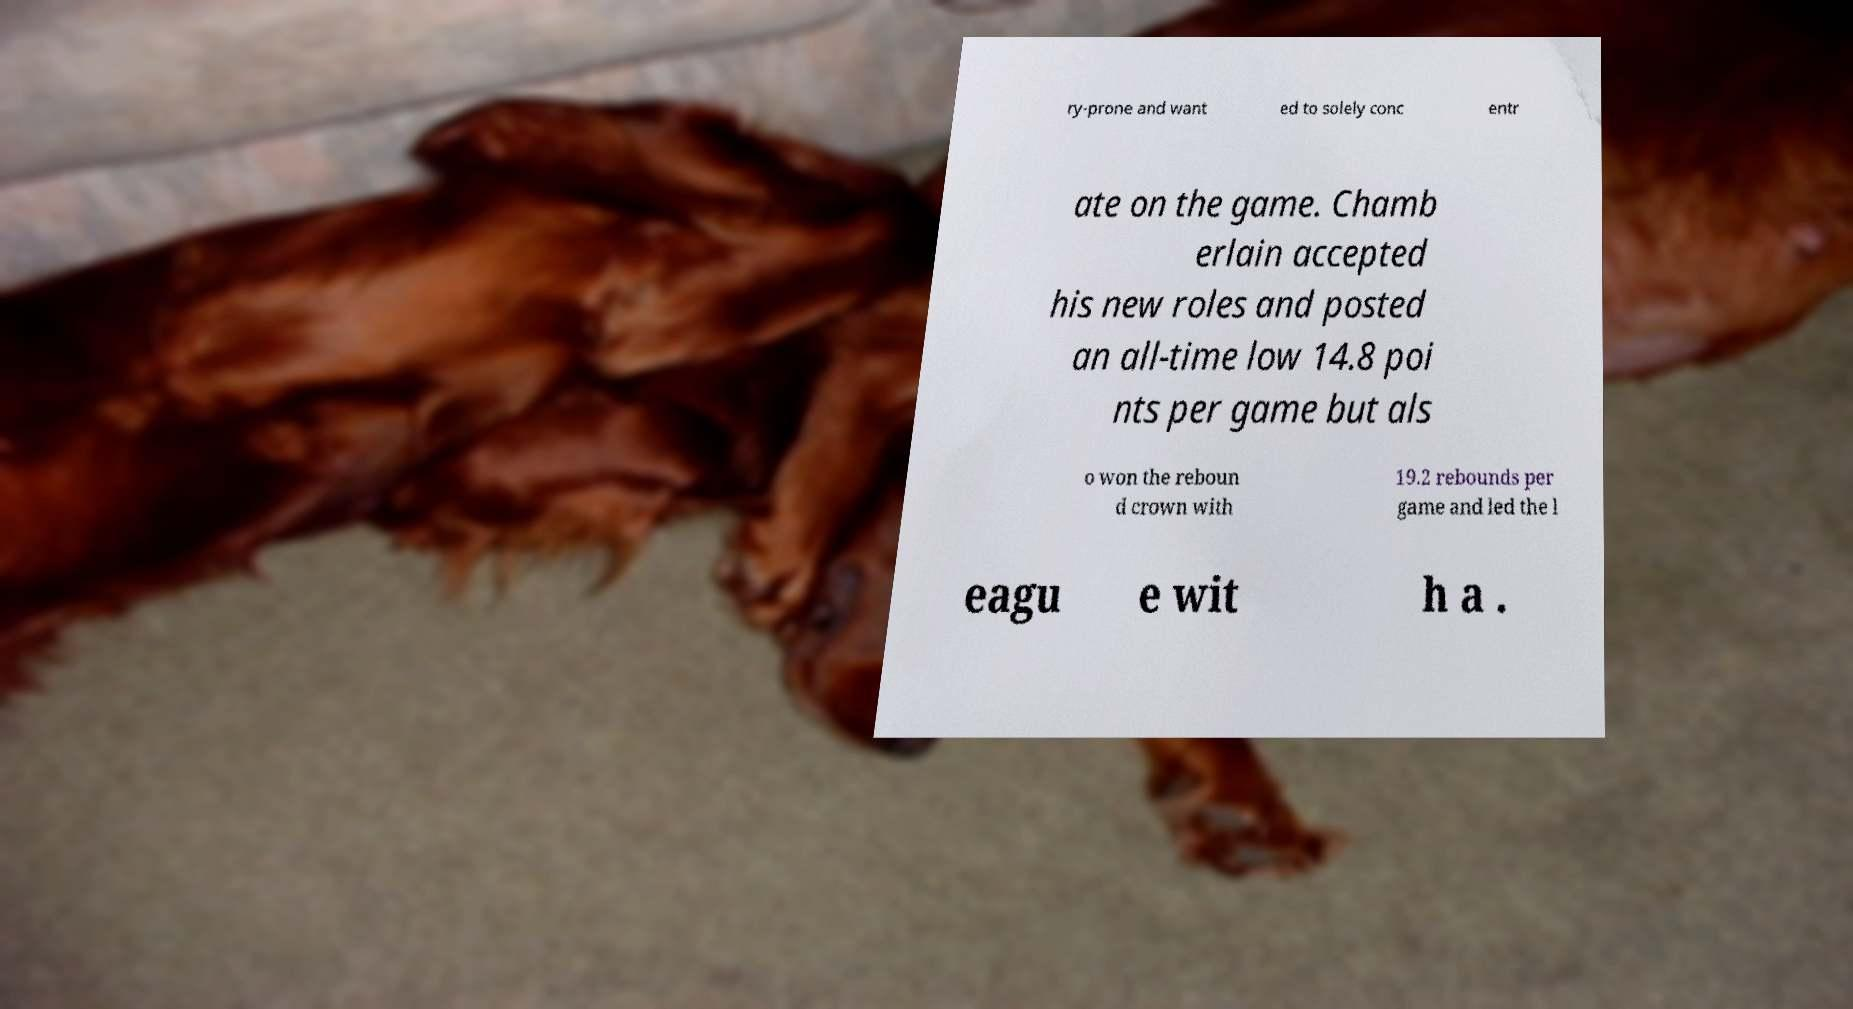Can you accurately transcribe the text from the provided image for me? ry-prone and want ed to solely conc entr ate on the game. Chamb erlain accepted his new roles and posted an all-time low 14.8 poi nts per game but als o won the reboun d crown with 19.2 rebounds per game and led the l eagu e wit h a . 